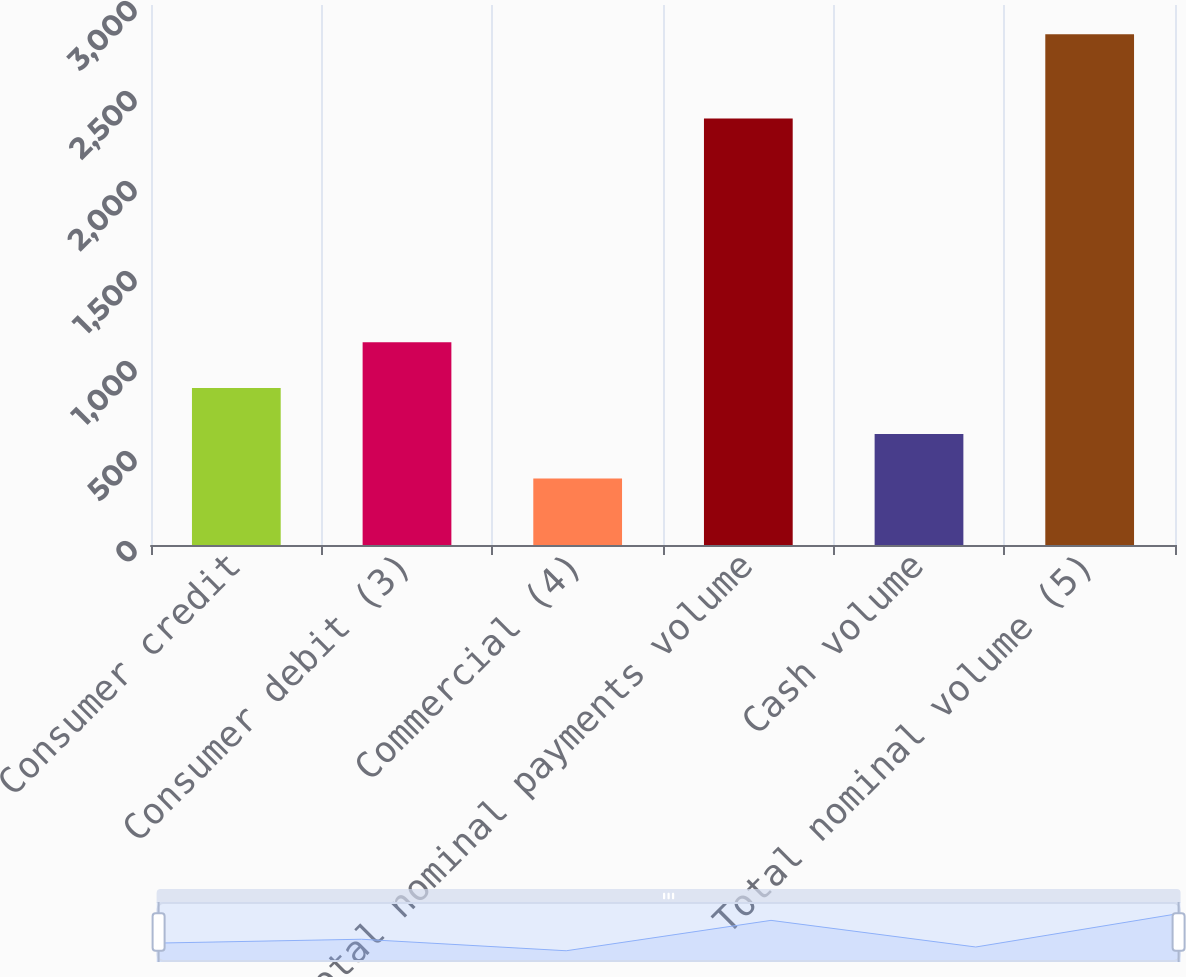Convert chart. <chart><loc_0><loc_0><loc_500><loc_500><bar_chart><fcel>Consumer credit<fcel>Consumer debit (3)<fcel>Commercial (4)<fcel>Total nominal payments volume<fcel>Cash volume<fcel>Total nominal volume (5)<nl><fcel>872<fcel>1127<fcel>370<fcel>2369<fcel>616.7<fcel>2837<nl></chart> 